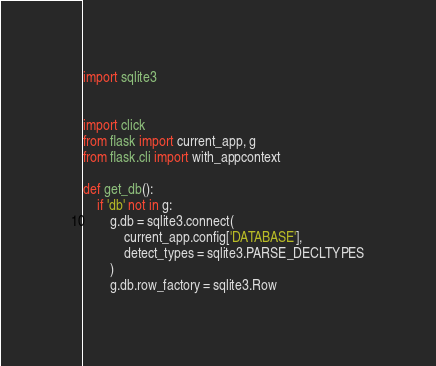<code> <loc_0><loc_0><loc_500><loc_500><_Python_>import sqlite3


import click
from flask import current_app, g
from flask.cli import with_appcontext

def get_db():
    if 'db' not in g:
        g.db = sqlite3.connect(
            current_app.config['DATABASE'],
            detect_types = sqlite3.PARSE_DECLTYPES
        )
        g.db.row_factory = sqlite3.Row
</code> 